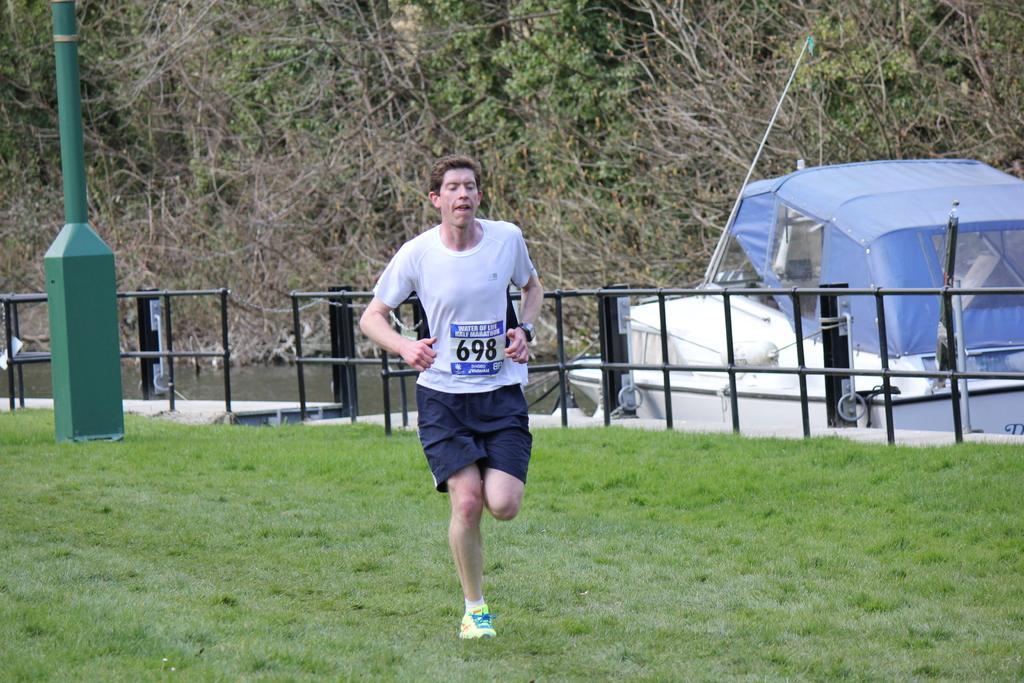In one or two sentences, can you explain what this image depicts? In this image, we can see a person is running on the grass. There is a sticker on his t-shirt. Background we can see rod fencing, pole, few boats, water. Top of the image, there are so many trees we can see. 